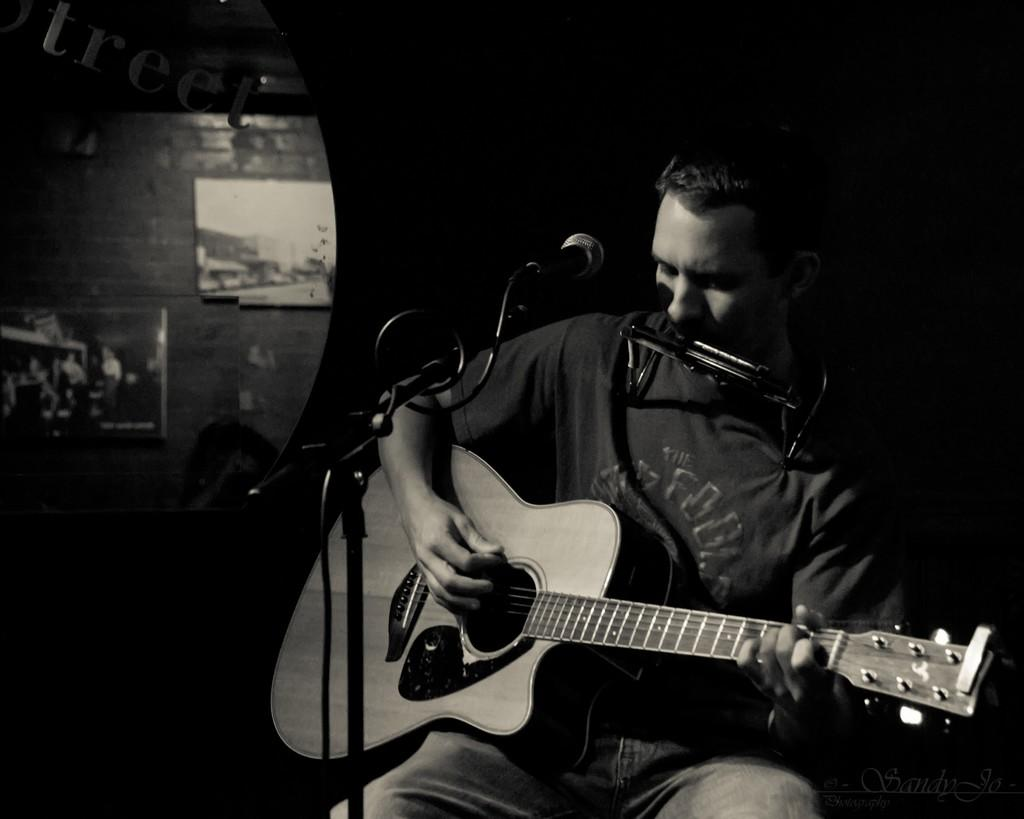What is the color scheme of the image? The image is black and white. What is the person in the image doing? The person is sitting on a chair and playing a guitar. What object is in front of the person? There is a microphone in front of the person. What can be seen in the background of the image? There is a wall in the background. How many bikes are parked next to the tent in the image? There are no bikes or tents present in the image. What achievement is the person being awarded for in the image? There is no indication of an award or achievement in the image; the person is simply playing a guitar. 